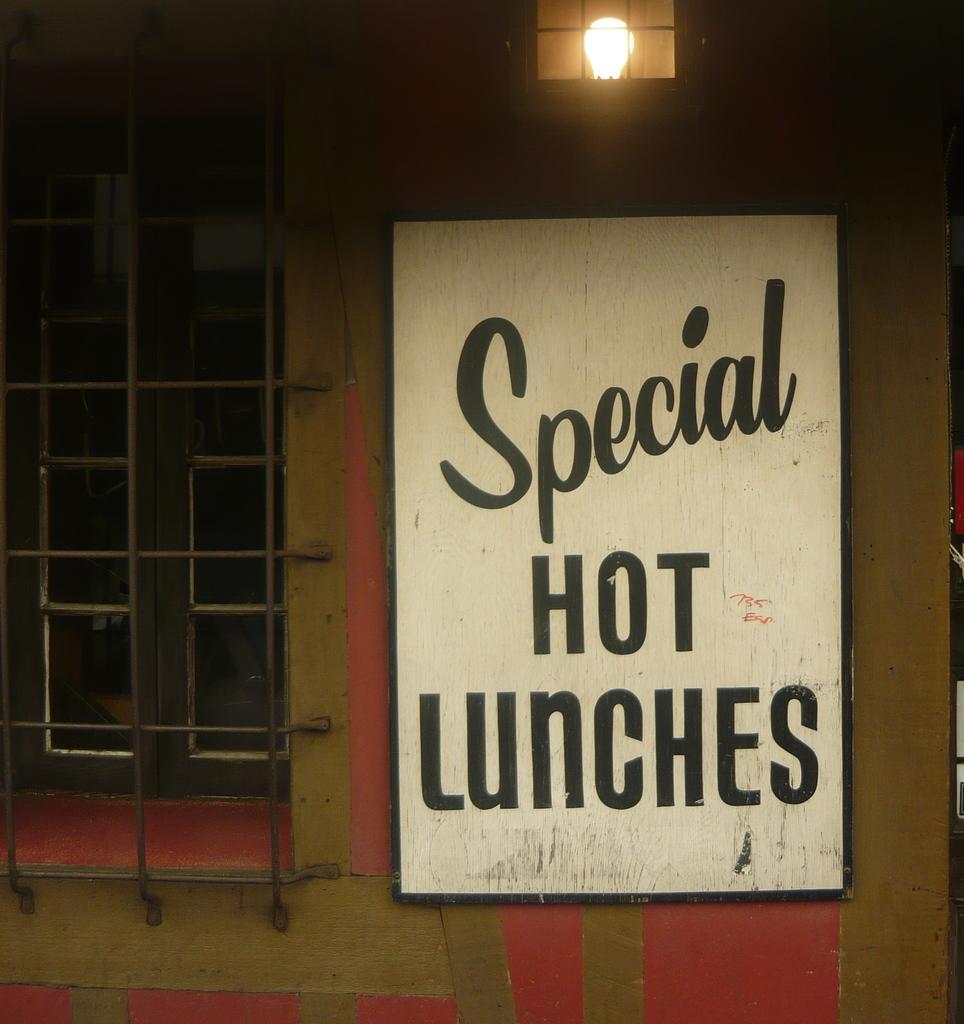Describe this image in one or two sentences. In this image we can see a board on a wall with some text on it. We can also see a window and a bulb with the metal grill. 